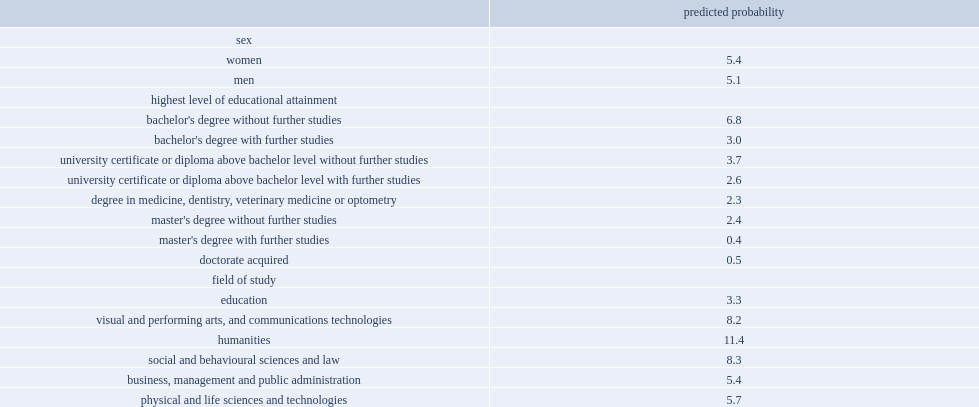List the top 3 fields of study least likely to experience persistent overqualification. Mathematics, computer and information sciences architecture, engineering, and related technologies health and related fields. What was the percentage of predicted probability of graduates in humanities programs being overqualified in both 2006 and 2016? 11.4. What were the predicted probabilities of graduates of programs in visual and performing arts and communications technology and in social and behavioural sciences and law being persistent overqualified? 8.2 8.3. List the top 3 locations of study least likely to be overqualified. Northern europe canada north america. What was the predicted probability of being overqulified for those who graduated in southern asia and southeast asia respectively? 18.2 20.4. 